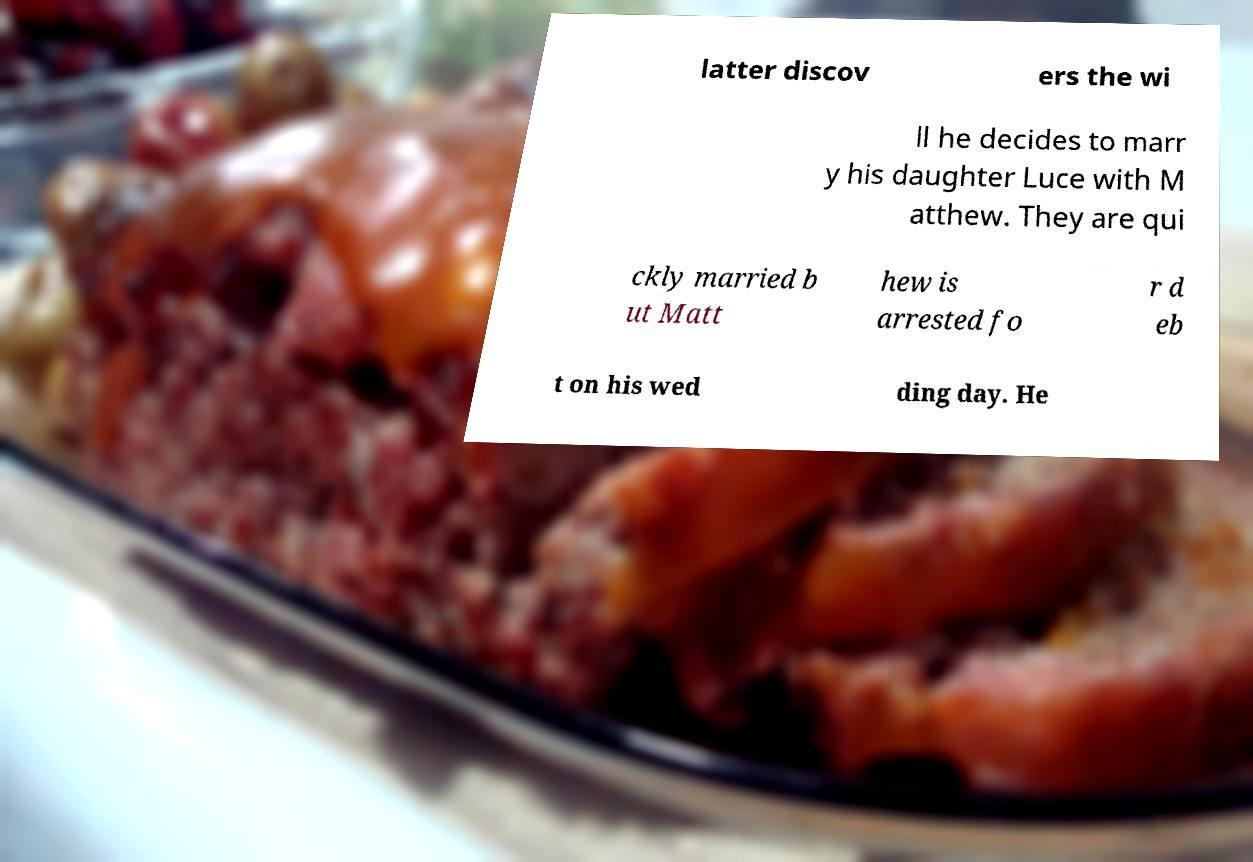Can you accurately transcribe the text from the provided image for me? latter discov ers the wi ll he decides to marr y his daughter Luce with M atthew. They are qui ckly married b ut Matt hew is arrested fo r d eb t on his wed ding day. He 